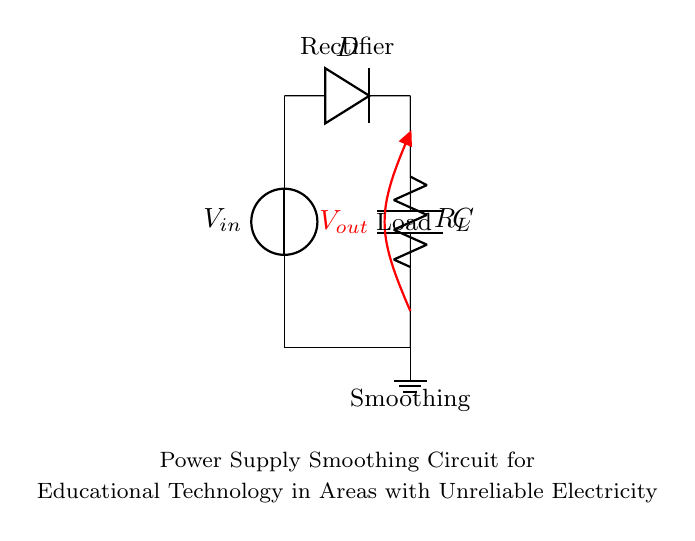What is the input voltage? The input voltage is labeled as V_in at the source on the left side of the circuit. It represents the power supply that the circuit will use.
Answer: V_in What type of component is D? D is labeled as a diode in the diagram. Its function is to allow current to pass in one direction, facilitating the conversion of alternating current (AC) to direct current (DC).
Answer: Diode What is the function of C? C is a smoothing capacitor that filters the output voltage, reducing ripples and providing a more stable DC output for the load.
Answer: Smoothing What happens to voltage across R_L? The voltage across the load resistor R_L is essentially the output voltage V_out, which is the voltage the load receives after smoothing from the capacitor.
Answer: V_out How does D affect the circuit during operation? The diode D ensures that current can only flow from the input to the output during the positive half-cycles of the input AC signal, preventing reverse current flow.
Answer: Prevents reverse current How is the total resistance in this circuit determined? In this circuit, the total resistance comes from R_L as it is the only resistor present in the diagram, thus directly impacting the current flowing through the load.
Answer: R_L What is the expected behavior of V_out when the capacitor C is absent? Without capacitor C, V_out would experience significant fluctuations and would not provide a smooth voltage supply for the load, which is crucial in areas with unstable electricity.
Answer: Fluctuations present 